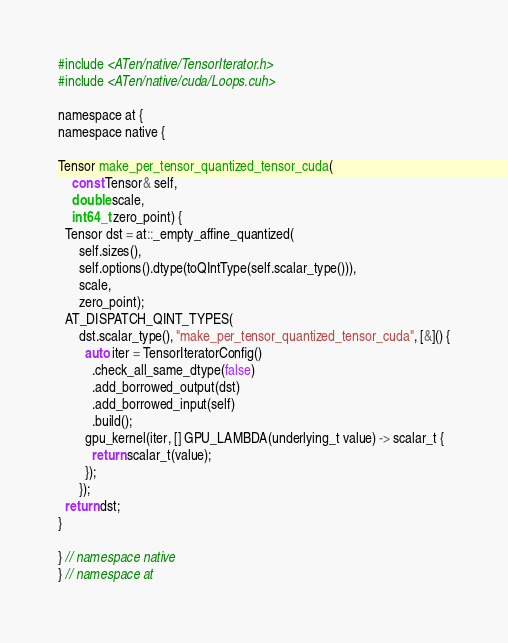Convert code to text. <code><loc_0><loc_0><loc_500><loc_500><_Cuda_>#include <ATen/native/TensorIterator.h>
#include <ATen/native/cuda/Loops.cuh>

namespace at {
namespace native {

Tensor make_per_tensor_quantized_tensor_cuda(
    const Tensor& self,
    double scale,
    int64_t zero_point) {
  Tensor dst = at::_empty_affine_quantized(
      self.sizes(),
      self.options().dtype(toQIntType(self.scalar_type())),
      scale,
      zero_point);
  AT_DISPATCH_QINT_TYPES(
      dst.scalar_type(), "make_per_tensor_quantized_tensor_cuda", [&]() {
        auto iter = TensorIteratorConfig()
          .check_all_same_dtype(false)
          .add_borrowed_output(dst)
          .add_borrowed_input(self)
          .build();
        gpu_kernel(iter, [] GPU_LAMBDA(underlying_t value) -> scalar_t {
          return scalar_t(value);
        });
      });
  return dst;
}

} // namespace native
} // namespace at
</code> 